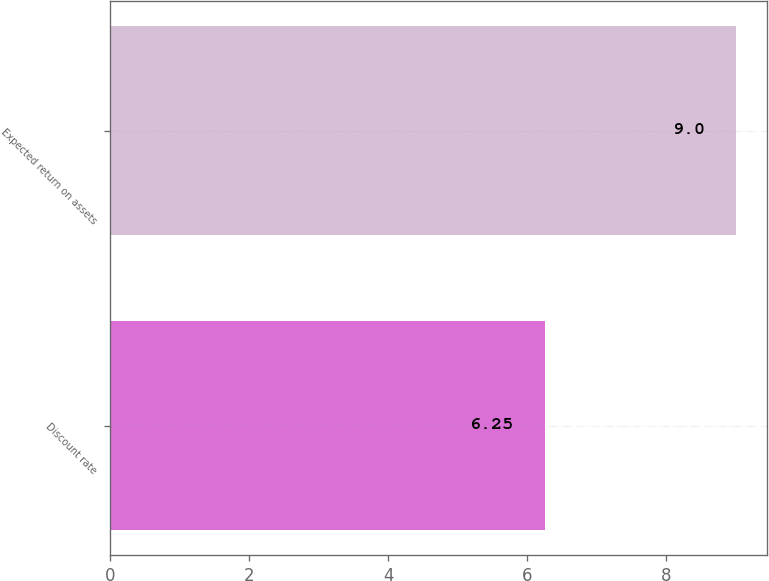Convert chart to OTSL. <chart><loc_0><loc_0><loc_500><loc_500><bar_chart><fcel>Discount rate<fcel>Expected return on assets<nl><fcel>6.25<fcel>9<nl></chart> 